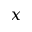Convert formula to latex. <formula><loc_0><loc_0><loc_500><loc_500>x</formula> 